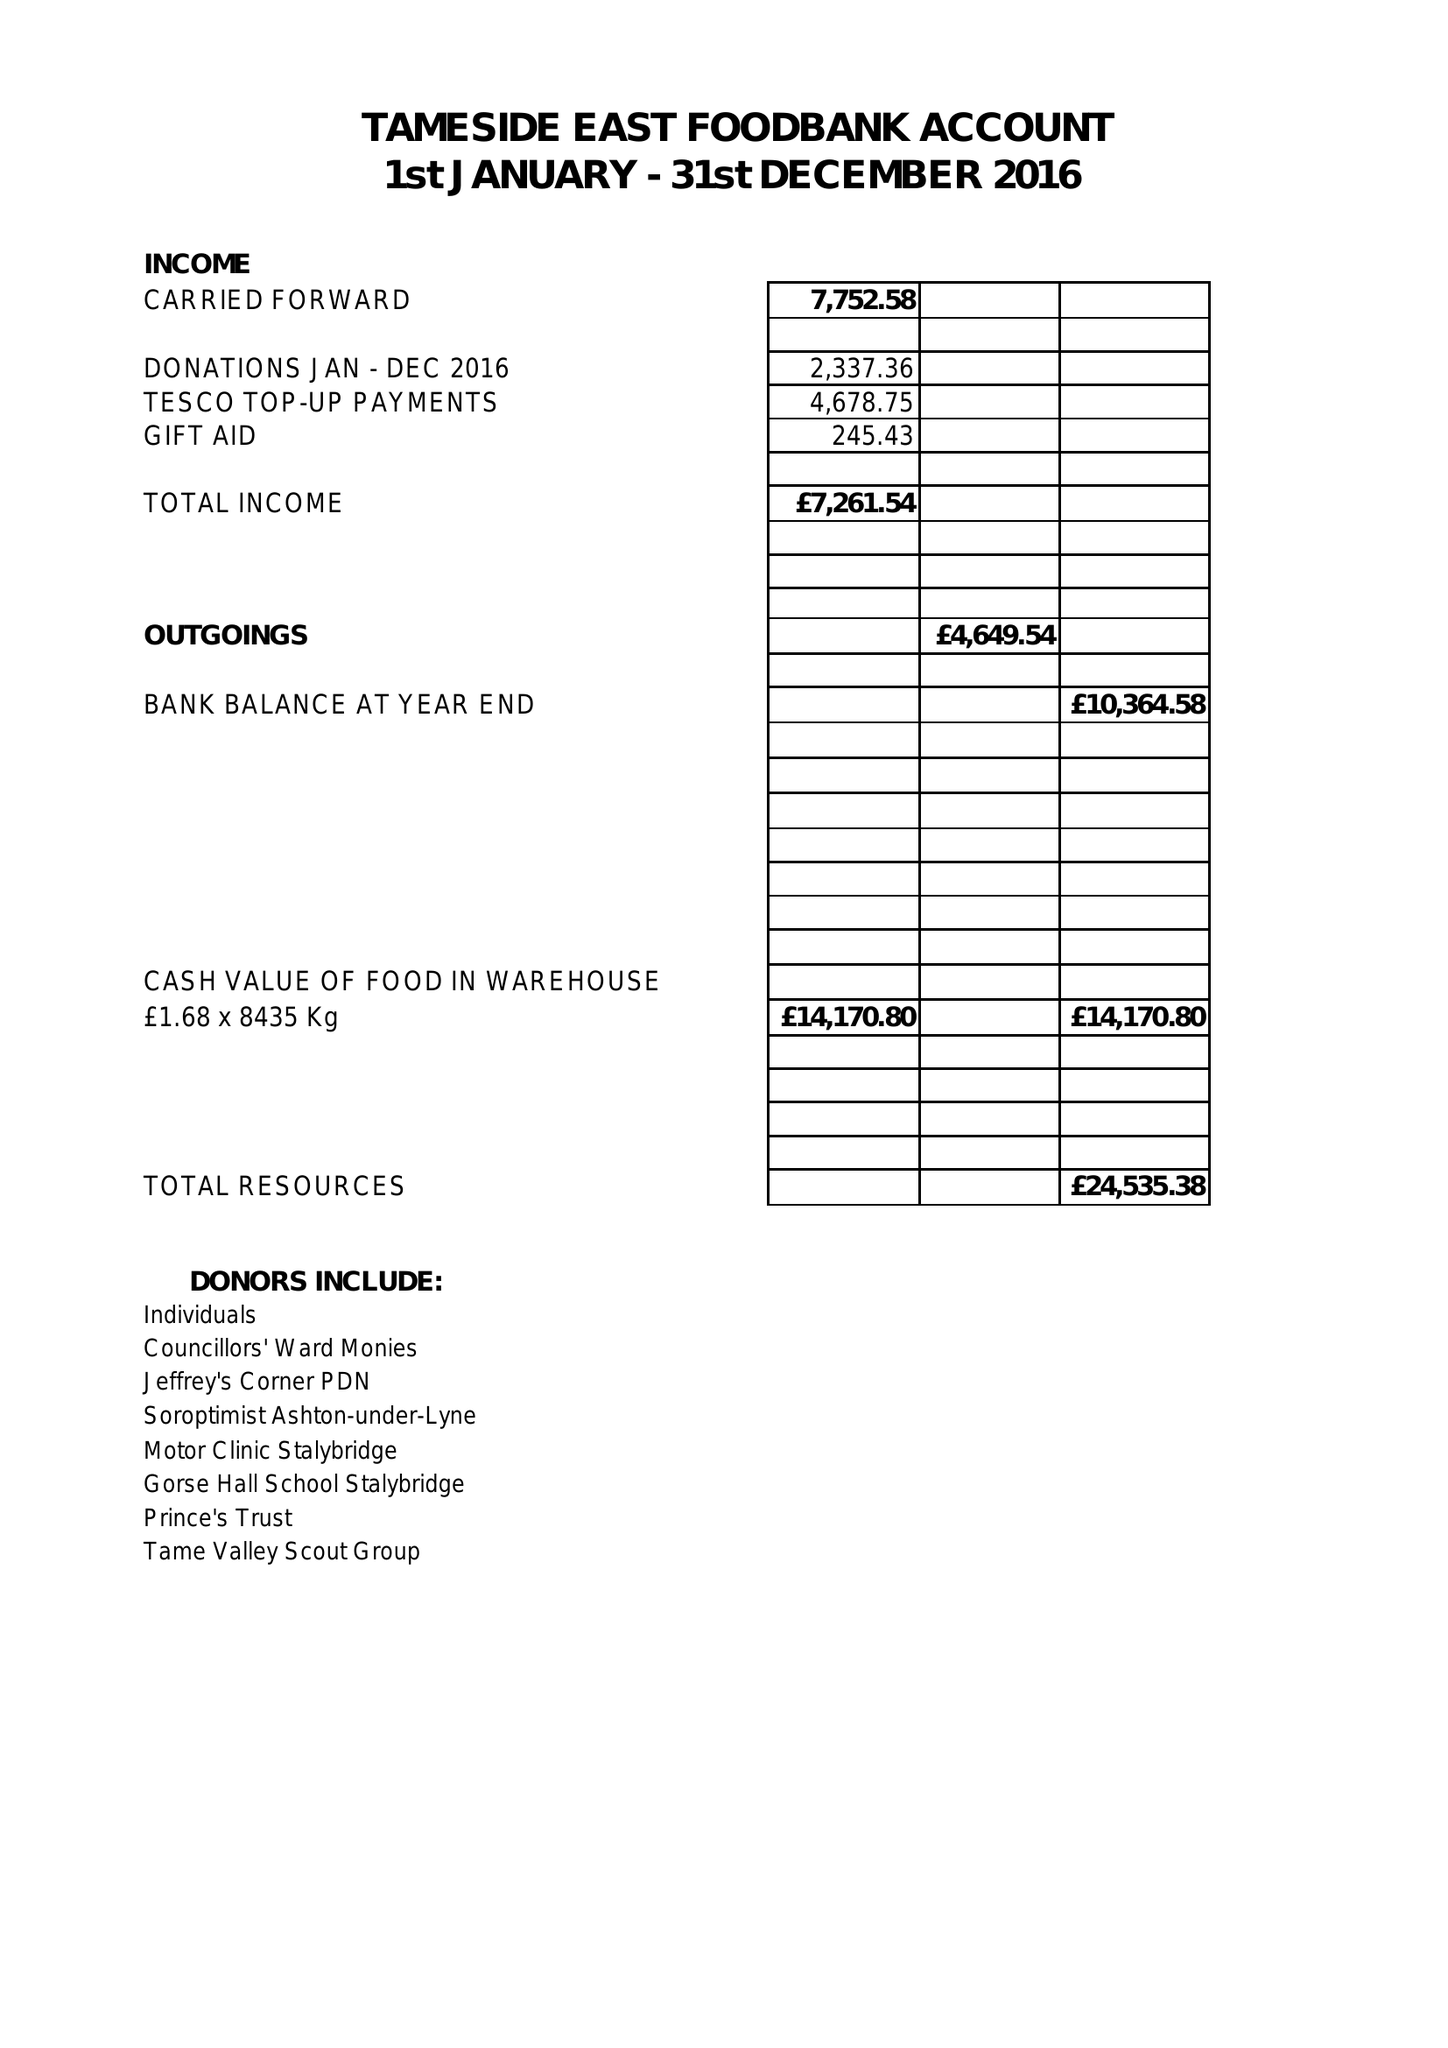What is the value for the spending_annually_in_british_pounds?
Answer the question using a single word or phrase. 4649.00 